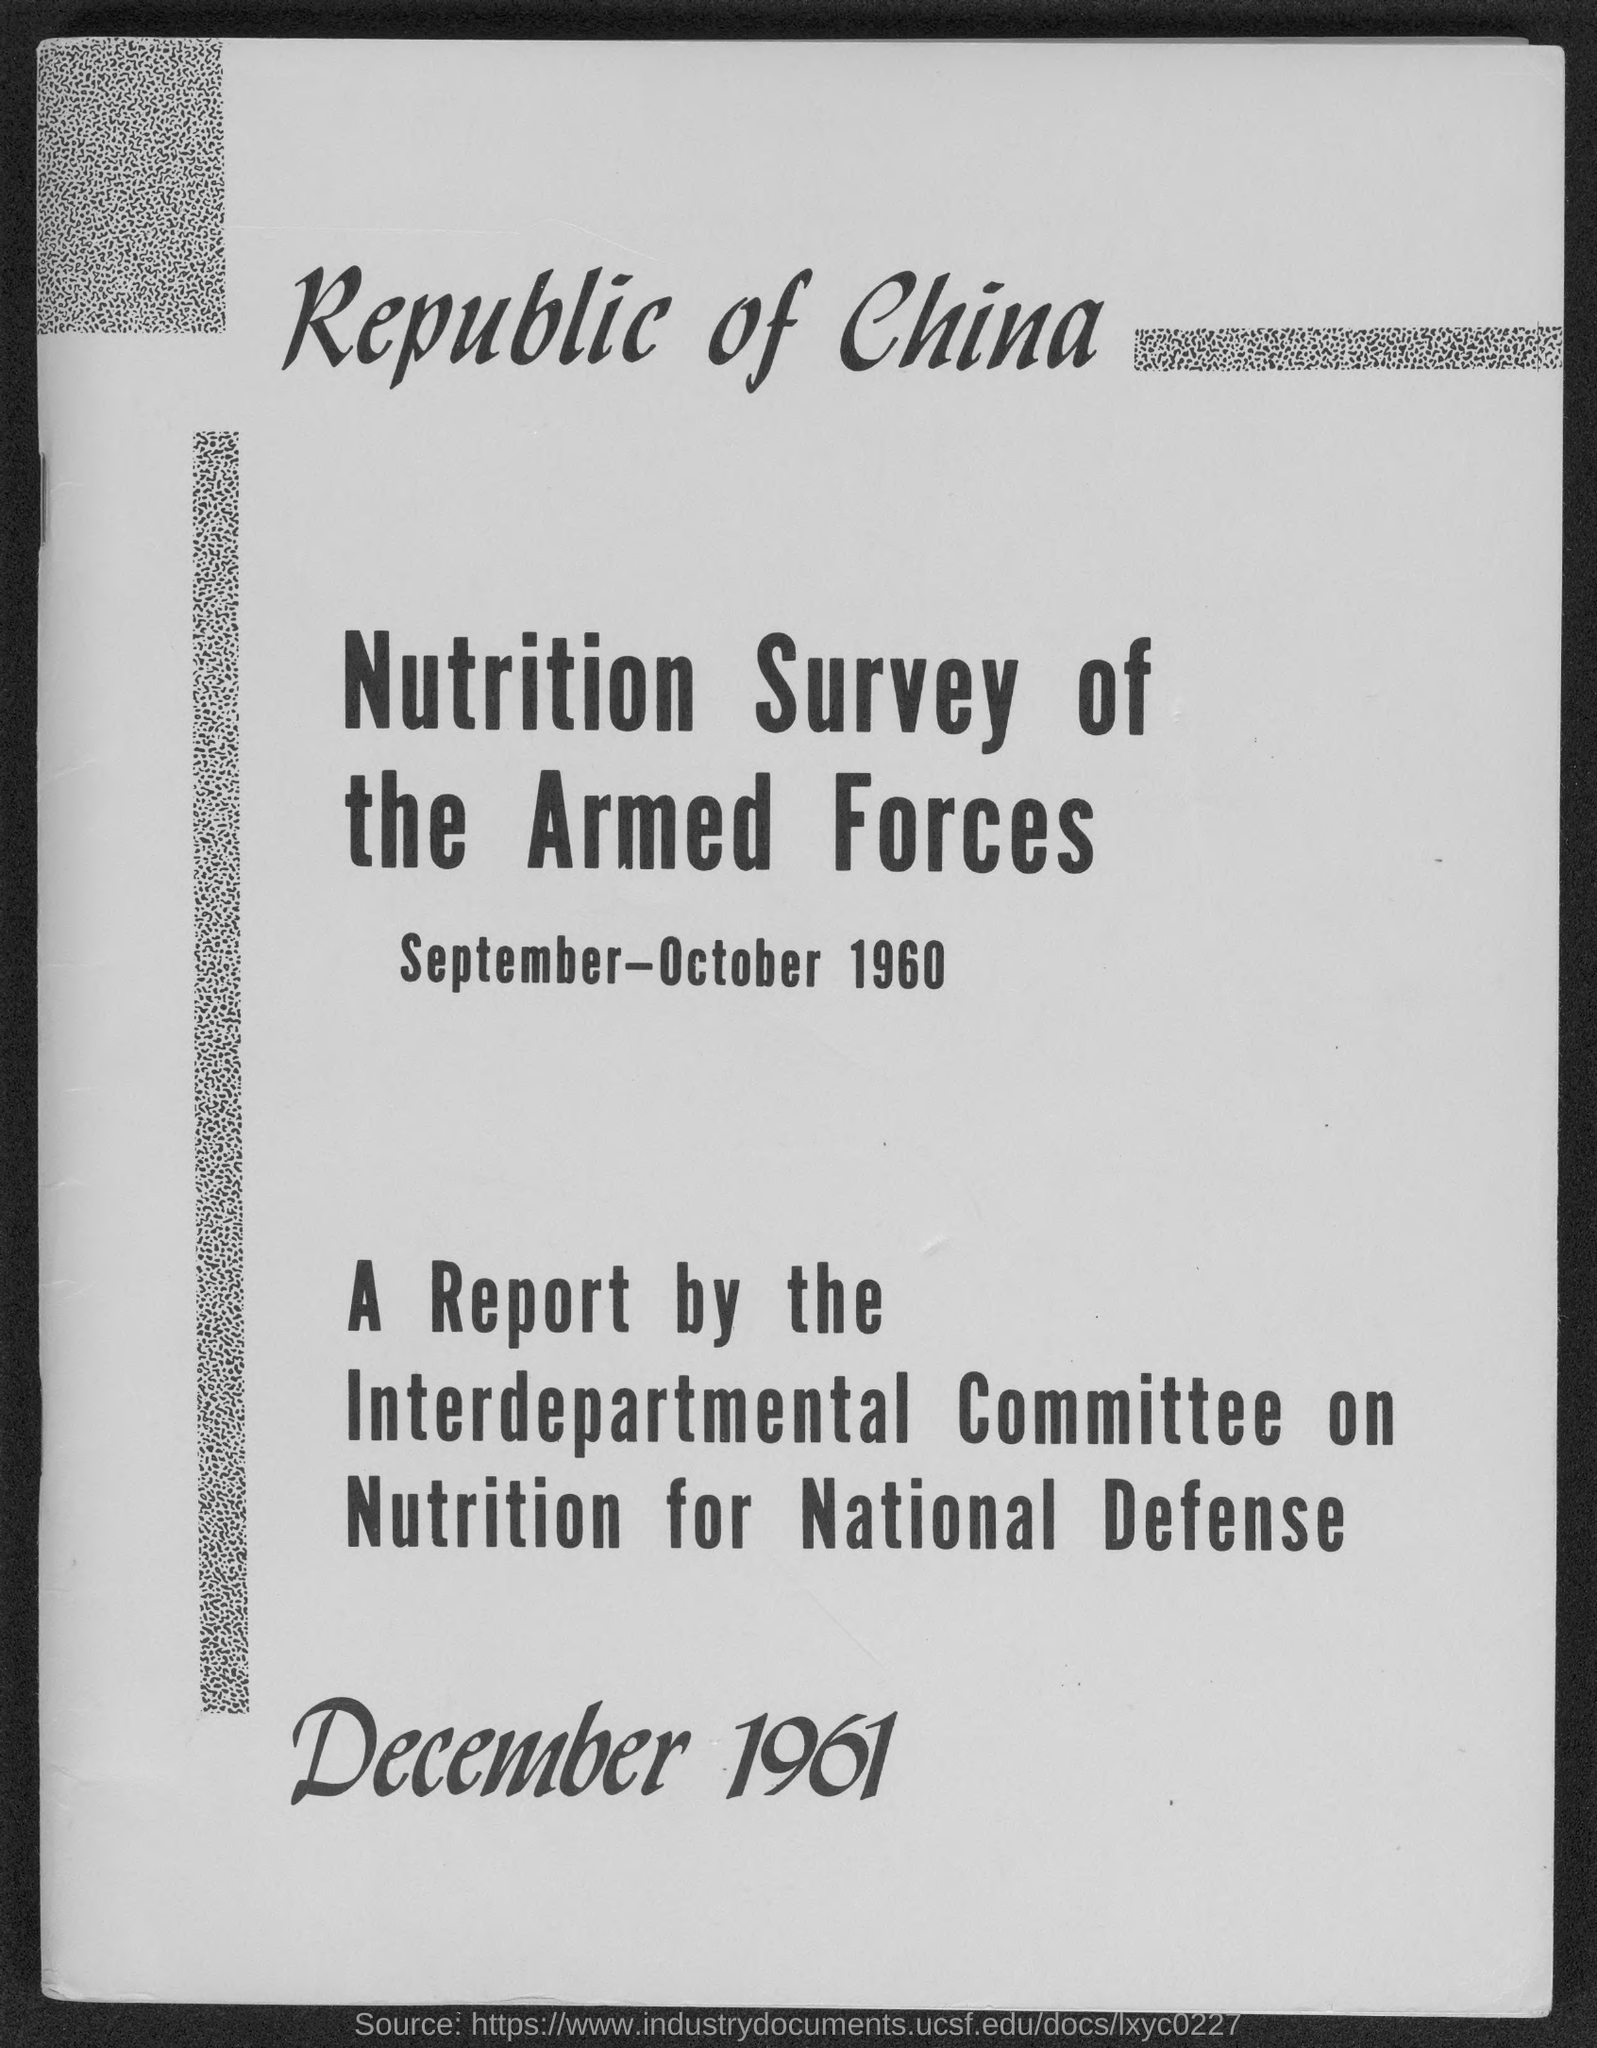List a handful of essential elements in this visual. The Interdepartmental Committee on Nutrition for National Defense was responsible for writing the report. 